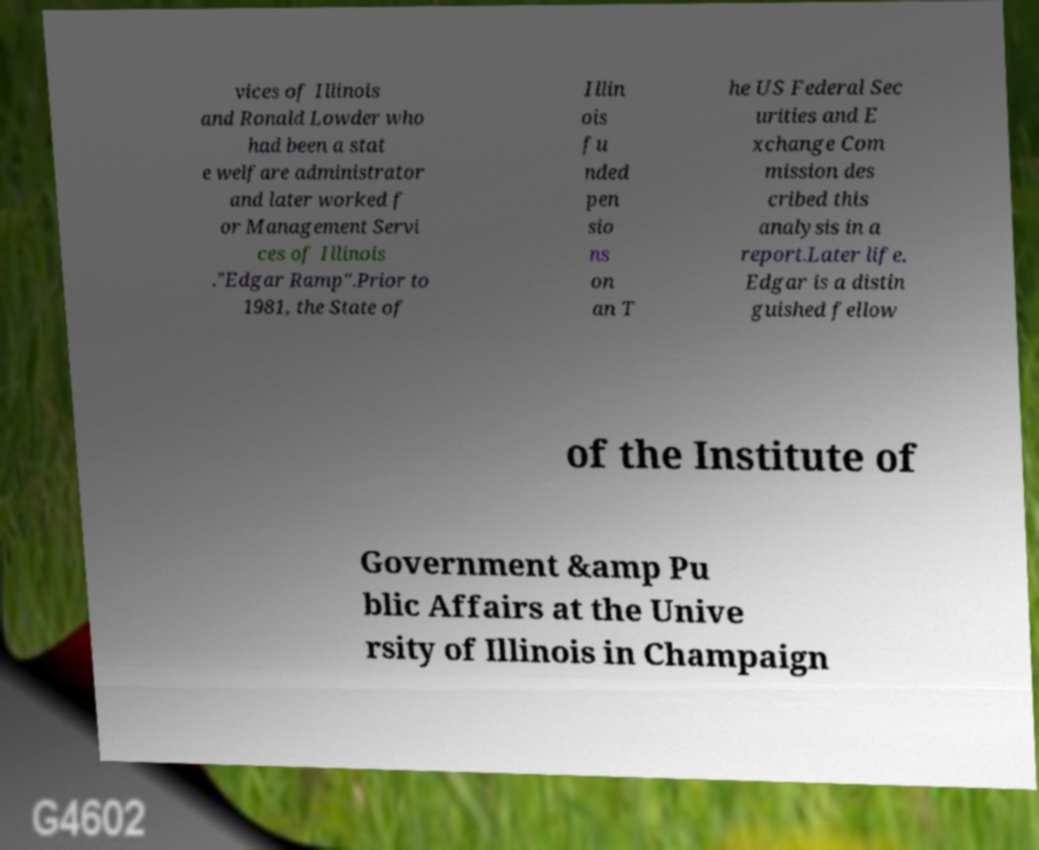Please identify and transcribe the text found in this image. vices of Illinois and Ronald Lowder who had been a stat e welfare administrator and later worked f or Management Servi ces of Illinois ."Edgar Ramp".Prior to 1981, the State of Illin ois fu nded pen sio ns on an T he US Federal Sec urities and E xchange Com mission des cribed this analysis in a report.Later life. Edgar is a distin guished fellow of the Institute of Government &amp Pu blic Affairs at the Unive rsity of Illinois in Champaign 